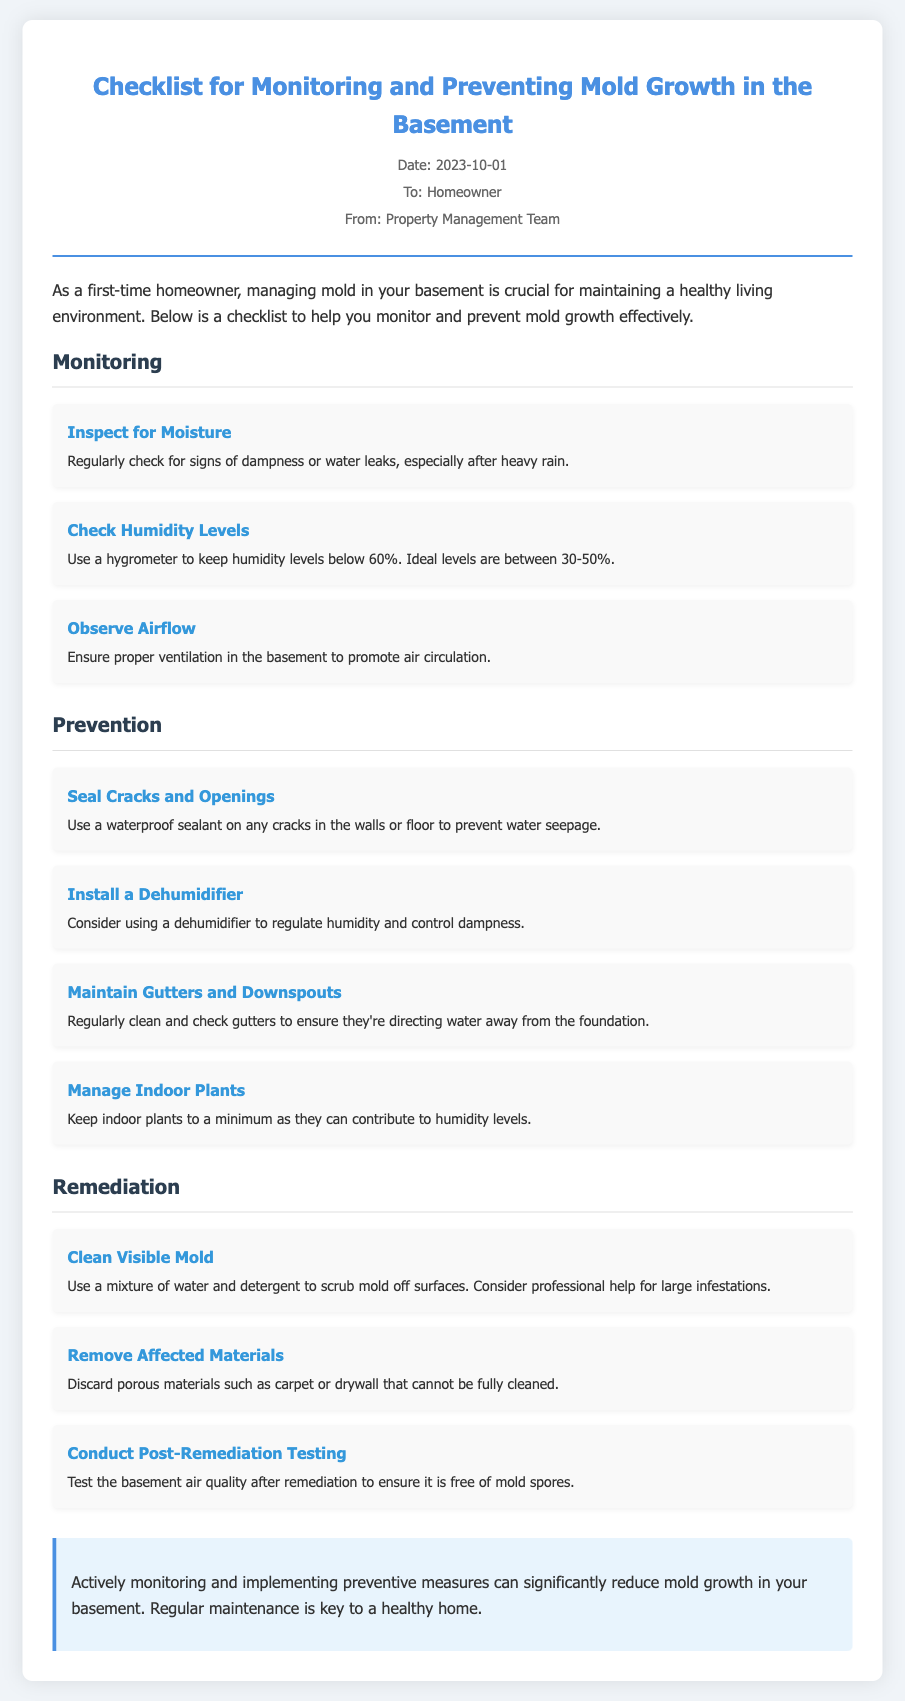what is the date of the memo? The date of the memo is specifically stated in the document.
Answer: 2023-10-01 who is the memo addressed to? The recipient of the memo is mentioned in the header section.
Answer: Homeowner what are ideal humidity levels according to the checklist? The document specifies the ideal humidity levels for the basement.
Answer: 30-50% how should visible mold be cleaned? The recommended method for cleaning visible mold is provided in the remediation section.
Answer: Water and detergent what is the first task in the monitoring section? The tasks are listed in order, and the first item addresses moisture.
Answer: Inspect for Moisture what should be done with porous materials affected by mold? The document outlines the appropriate action for contaminated porous materials.
Answer: Discard how many tasks are listed under the prevention section? The number of tasks is determined by counting the items listed in that section.
Answer: Four what is suggested for regulating humidity? The checklist recommends a specific device for managing humidity levels.
Answer: Dehumidifier what type of testing is suggested after remediation? The memo describes a specific test that should take place after addressing mold issues.
Answer: Post-Remediation Testing 